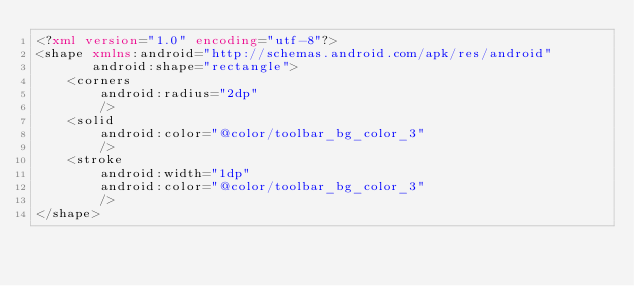Convert code to text. <code><loc_0><loc_0><loc_500><loc_500><_XML_><?xml version="1.0" encoding="utf-8"?>
<shape xmlns:android="http://schemas.android.com/apk/res/android"
	   android:shape="rectangle">
	<corners
		android:radius="2dp"
		/>
	<solid
		android:color="@color/toolbar_bg_color_3"
		/>
	<stroke
		android:width="1dp"
		android:color="@color/toolbar_bg_color_3"
		/>
</shape></code> 